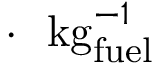<formula> <loc_0><loc_0><loc_500><loc_500>\cdot \ \ { k g _ { f u e l } ^ { - 1 } }</formula> 